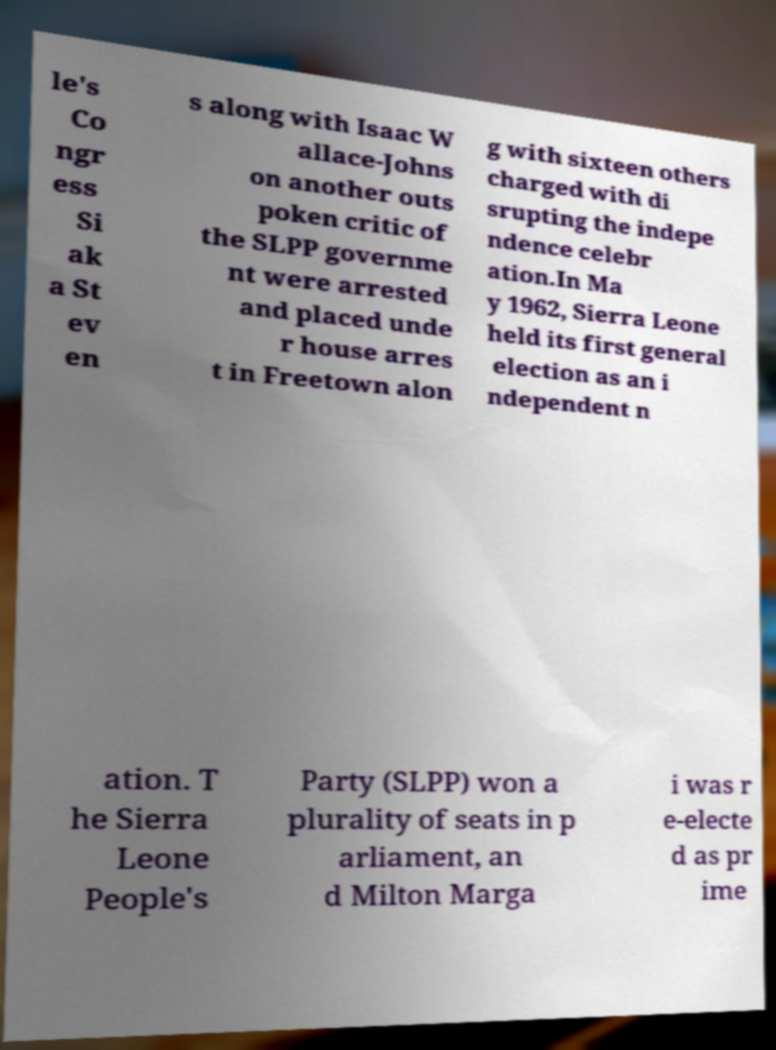For documentation purposes, I need the text within this image transcribed. Could you provide that? le's Co ngr ess Si ak a St ev en s along with Isaac W allace-Johns on another outs poken critic of the SLPP governme nt were arrested and placed unde r house arres t in Freetown alon g with sixteen others charged with di srupting the indepe ndence celebr ation.In Ma y 1962, Sierra Leone held its first general election as an i ndependent n ation. T he Sierra Leone People's Party (SLPP) won a plurality of seats in p arliament, an d Milton Marga i was r e-electe d as pr ime 